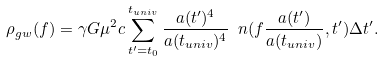Convert formula to latex. <formula><loc_0><loc_0><loc_500><loc_500>\rho _ { g w } ( f ) = \gamma G \mu ^ { 2 } c \sum _ { t ^ { \prime } = t _ { 0 } } ^ { t _ { u n i v } } \frac { a ( t ^ { \prime } ) ^ { 4 } } { a ( t _ { u n i v } ) ^ { 4 } } \ n ( f \frac { a ( t ^ { \prime } ) } { a ( t _ { u n i v } ) } , t ^ { \prime } ) \Delta t ^ { \prime } .</formula> 